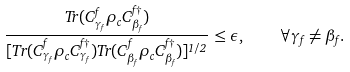Convert formula to latex. <formula><loc_0><loc_0><loc_500><loc_500>\frac { T r ( C ^ { f } _ { \gamma _ { f } } \rho _ { c } C _ { \beta _ { f } } ^ { f \dagger } ) } { [ T r ( C ^ { f } _ { \gamma _ { f } } \rho _ { c } C _ { \gamma _ { f } } ^ { f \dagger } ) T r ( C ^ { f } _ { \beta _ { f } } \rho _ { c } C _ { \beta _ { f } } ^ { f \dagger } ) ] ^ { 1 / 2 } } \leq \epsilon , \quad \forall \gamma _ { f } \neq \beta _ { f } .</formula> 